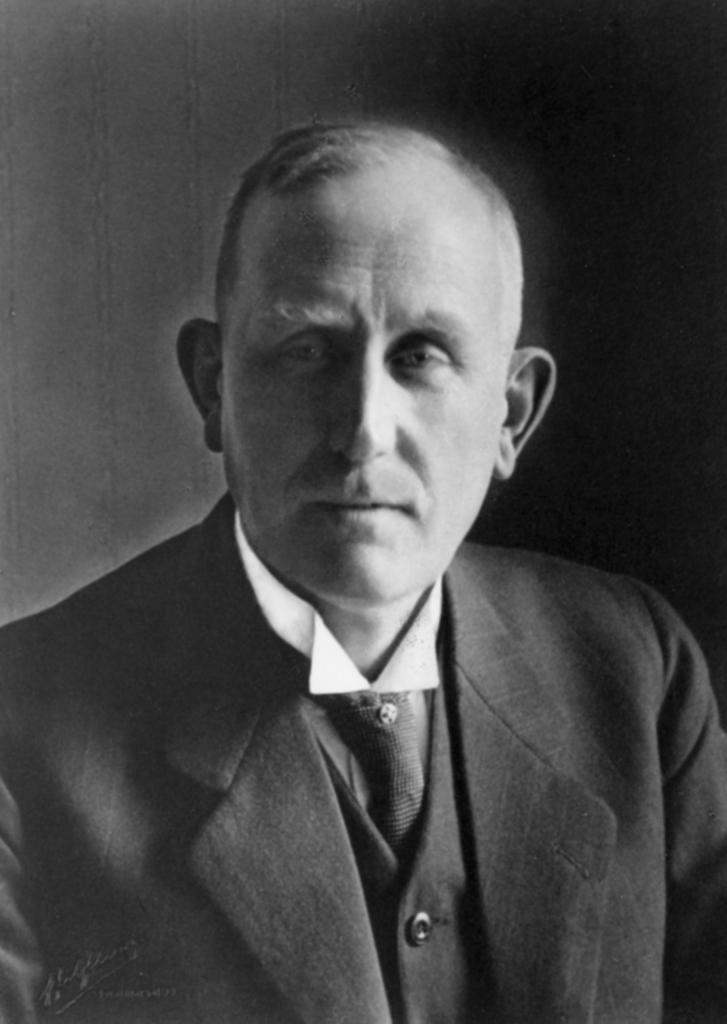Can you describe this image briefly? This is a black and white picture. In this picture, we see a man is wearing a white shirt and black blazer. In the background, it is black in color. This picture might be a photo frame. 